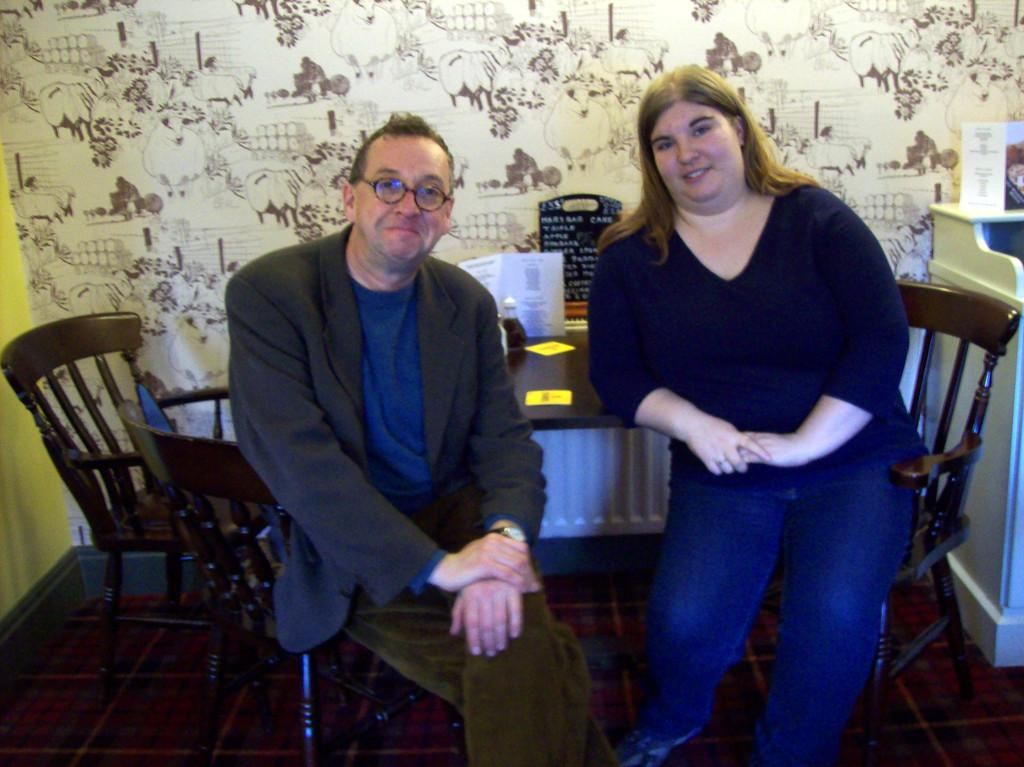What is present in the image that can be used for covering or cleaning? There is a cloth in the image that can be used for covering or cleaning. How many people are sitting in the image? There are two people sitting on chairs in the image. What is the main piece of furniture in the image? There is a table in the image. What is placed on the table? There is a poster and a bottle on the table. Can you see any cracks on the sidewalk in the image? There is no sidewalk present in the image. What type of stove is used to cook the crackers in the image? There are no crackers or stove present in the image. 